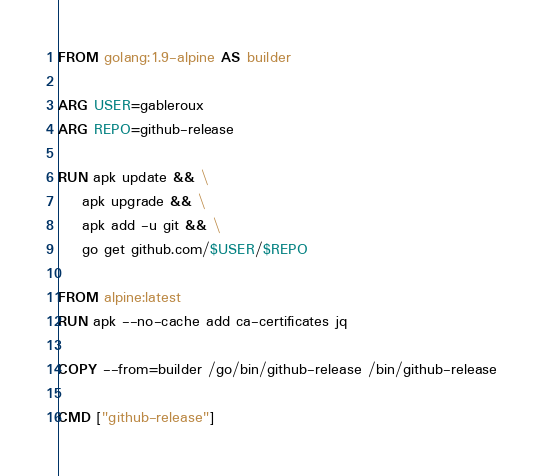<code> <loc_0><loc_0><loc_500><loc_500><_Dockerfile_>FROM golang:1.9-alpine AS builder

ARG USER=gableroux
ARG REPO=github-release

RUN apk update && \
    apk upgrade && \
    apk add -u git && \
    go get github.com/$USER/$REPO

FROM alpine:latest
RUN apk --no-cache add ca-certificates jq

COPY --from=builder /go/bin/github-release /bin/github-release

CMD ["github-release"]
</code> 